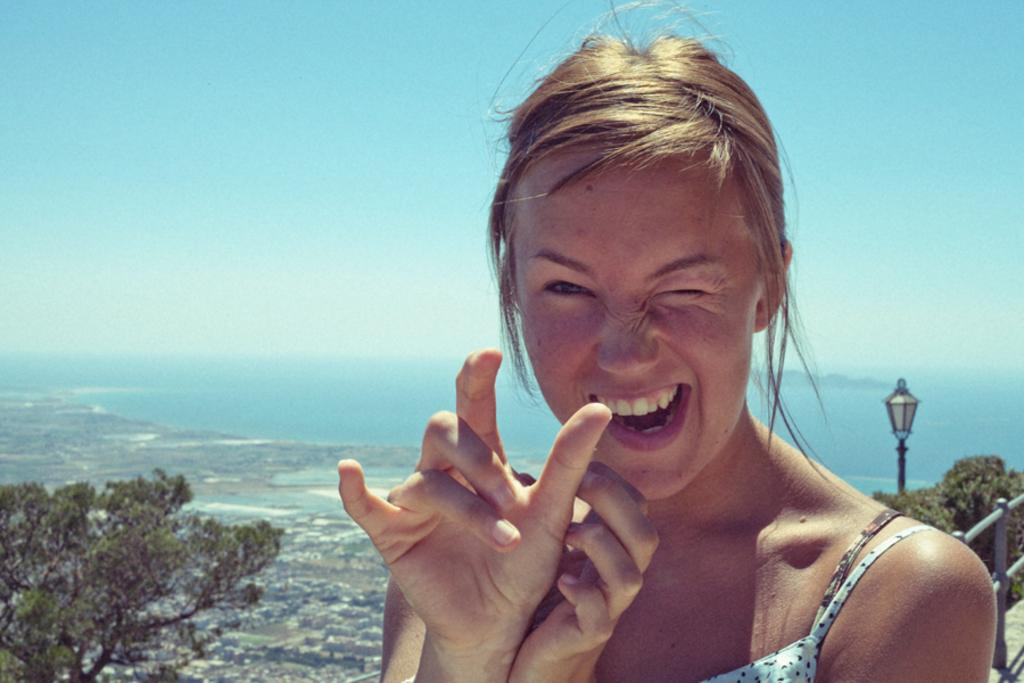Who is present in the image? There is a woman in the image. What can be seen in the background behind the woman? There are trees visible behind the woman. What type of illumination is present in the image? There is a light in the image. What material is used for the rods in the image? There are metal rods in the image. What type of quill is the woman using to write in the image? There is no quill present in the image, and the woman is not shown writing. 